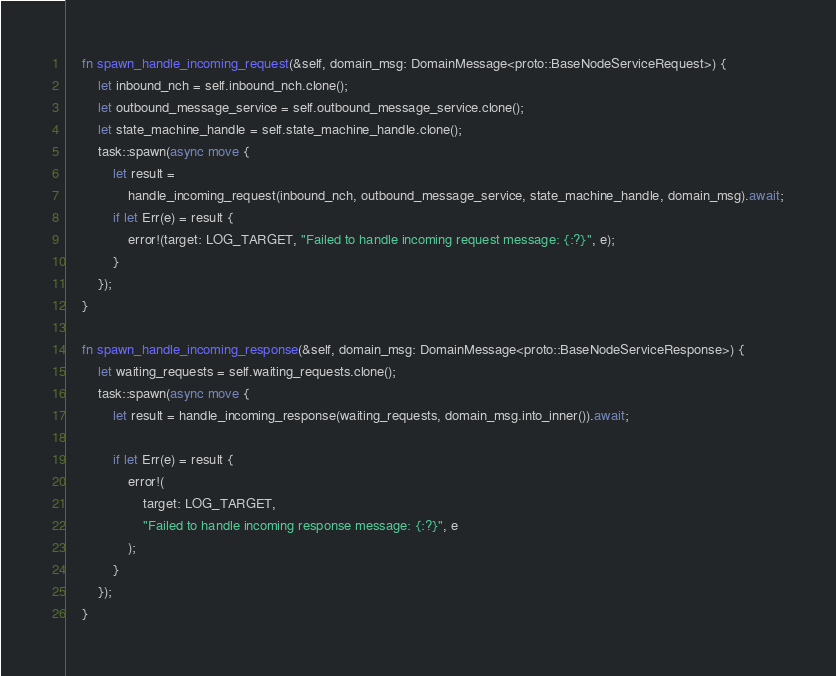<code> <loc_0><loc_0><loc_500><loc_500><_Rust_>    fn spawn_handle_incoming_request(&self, domain_msg: DomainMessage<proto::BaseNodeServiceRequest>) {
        let inbound_nch = self.inbound_nch.clone();
        let outbound_message_service = self.outbound_message_service.clone();
        let state_machine_handle = self.state_machine_handle.clone();
        task::spawn(async move {
            let result =
                handle_incoming_request(inbound_nch, outbound_message_service, state_machine_handle, domain_msg).await;
            if let Err(e) = result {
                error!(target: LOG_TARGET, "Failed to handle incoming request message: {:?}", e);
            }
        });
    }

    fn spawn_handle_incoming_response(&self, domain_msg: DomainMessage<proto::BaseNodeServiceResponse>) {
        let waiting_requests = self.waiting_requests.clone();
        task::spawn(async move {
            let result = handle_incoming_response(waiting_requests, domain_msg.into_inner()).await;

            if let Err(e) = result {
                error!(
                    target: LOG_TARGET,
                    "Failed to handle incoming response message: {:?}", e
                );
            }
        });
    }
</code> 